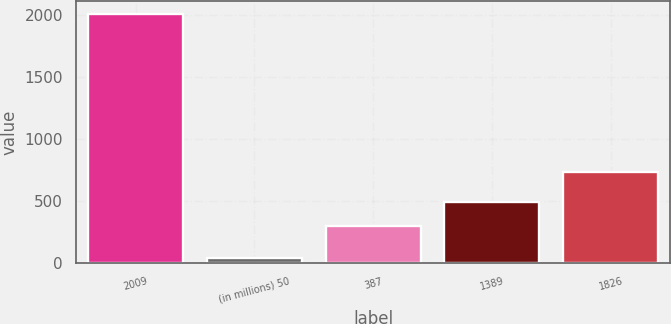<chart> <loc_0><loc_0><loc_500><loc_500><bar_chart><fcel>2009<fcel>(in millions) 50<fcel>387<fcel>1389<fcel>1826<nl><fcel>2008<fcel>44<fcel>298<fcel>494.4<fcel>734<nl></chart> 